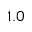<formula> <loc_0><loc_0><loc_500><loc_500>1 . 0</formula> 